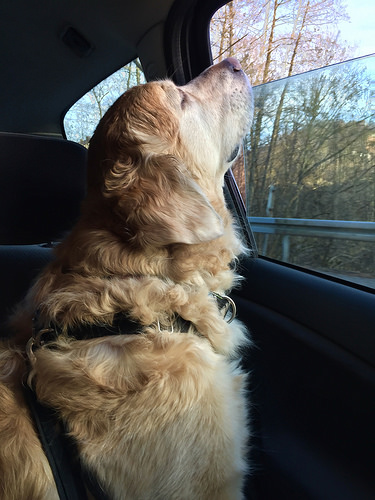<image>
Is there a dog next to the car? No. The dog is not positioned next to the car. They are located in different areas of the scene. Is there a window behind the dog? Yes. From this viewpoint, the window is positioned behind the dog, with the dog partially or fully occluding the window. 